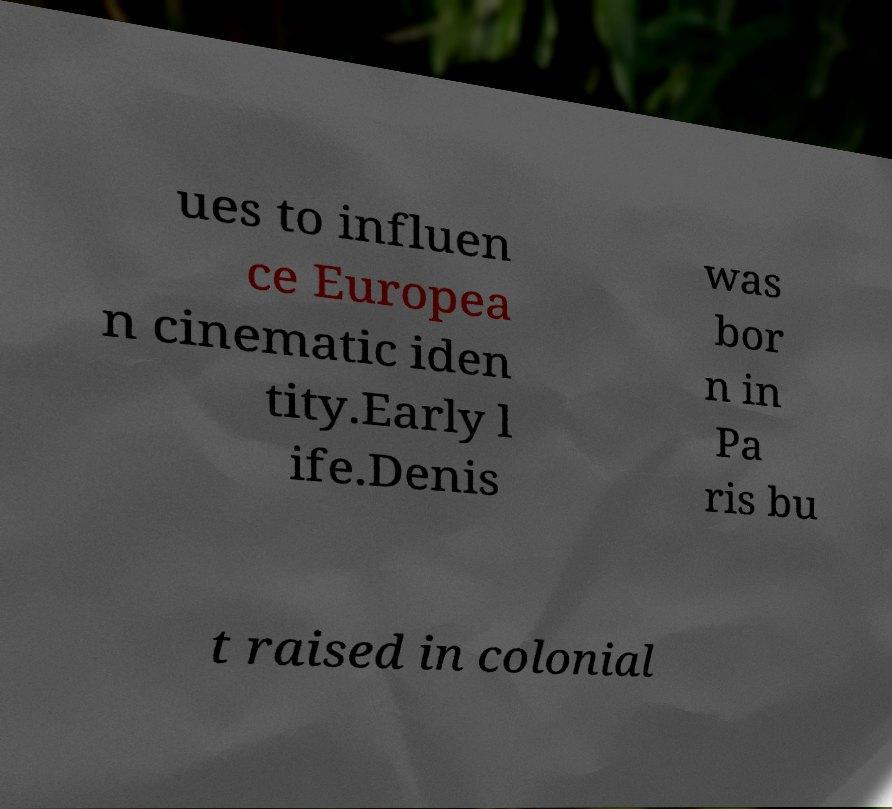Could you extract and type out the text from this image? ues to influen ce Europea n cinematic iden tity.Early l ife.Denis was bor n in Pa ris bu t raised in colonial 